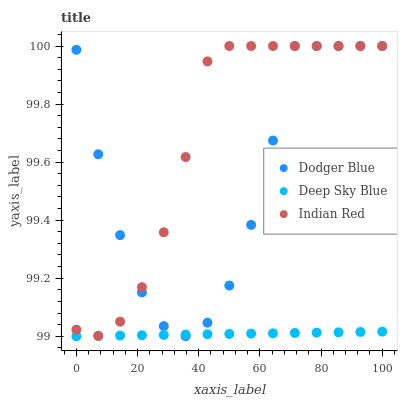Does Deep Sky Blue have the minimum area under the curve?
Answer yes or no. Yes. Does Indian Red have the maximum area under the curve?
Answer yes or no. Yes. Does Indian Red have the minimum area under the curve?
Answer yes or no. No. Does Deep Sky Blue have the maximum area under the curve?
Answer yes or no. No. Is Deep Sky Blue the smoothest?
Answer yes or no. Yes. Is Dodger Blue the roughest?
Answer yes or no. Yes. Is Indian Red the smoothest?
Answer yes or no. No. Is Indian Red the roughest?
Answer yes or no. No. Does Deep Sky Blue have the lowest value?
Answer yes or no. Yes. Does Indian Red have the lowest value?
Answer yes or no. No. Does Indian Red have the highest value?
Answer yes or no. Yes. Does Deep Sky Blue have the highest value?
Answer yes or no. No. Is Deep Sky Blue less than Indian Red?
Answer yes or no. Yes. Is Indian Red greater than Deep Sky Blue?
Answer yes or no. Yes. Does Indian Red intersect Dodger Blue?
Answer yes or no. Yes. Is Indian Red less than Dodger Blue?
Answer yes or no. No. Is Indian Red greater than Dodger Blue?
Answer yes or no. No. Does Deep Sky Blue intersect Indian Red?
Answer yes or no. No. 